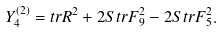Convert formula to latex. <formula><loc_0><loc_0><loc_500><loc_500>Y _ { 4 } ^ { ( 2 ) } = t r R ^ { 2 } + 2 S t r F _ { 9 } ^ { 2 } - 2 S t r F _ { 5 } ^ { 2 } .</formula> 